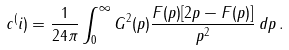<formula> <loc_0><loc_0><loc_500><loc_500>c ^ { ( } i ) = \frac { 1 } { 2 4 \pi } \int _ { 0 } ^ { \infty } G ^ { 2 } ( p ) \frac { F ( p ) [ 2 p - F ( p ) ] } { p ^ { 2 } } \, d p \, .</formula> 